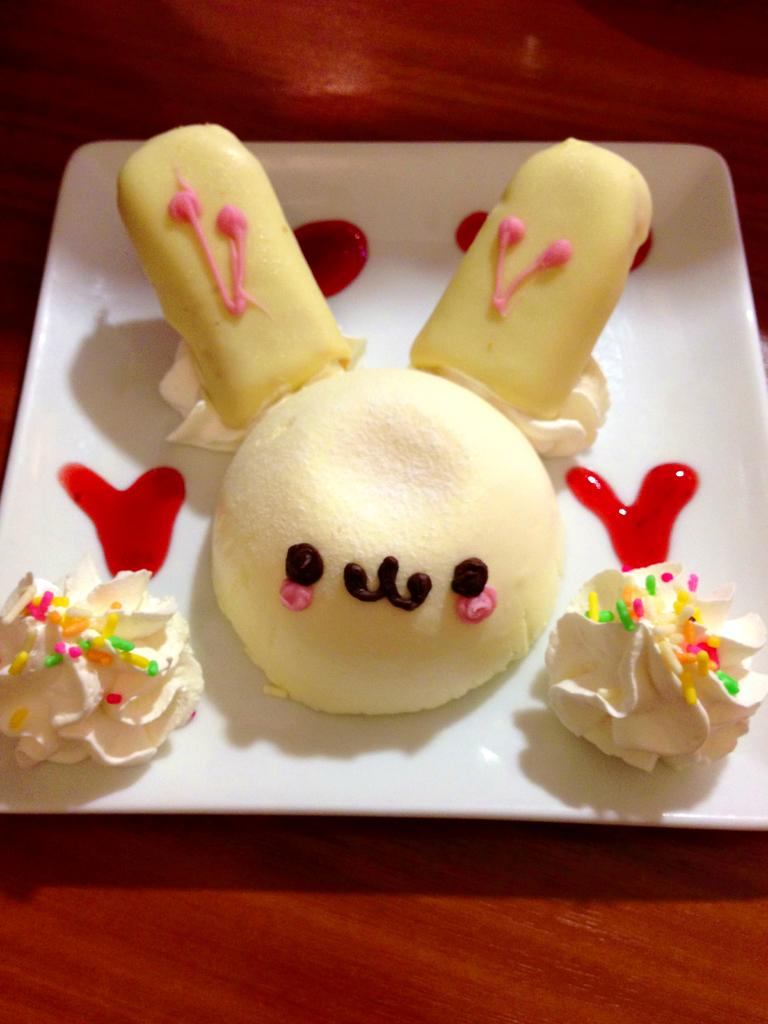What is on the plate that is visible in the image? There are food items on a plate in the image. Where is the plate located in the image? The plate is on a table at the bottom of the image. What type of cloth is being sold at the market in the image? There is no market or cloth present in the image; it only features a plate of food items on a table. 